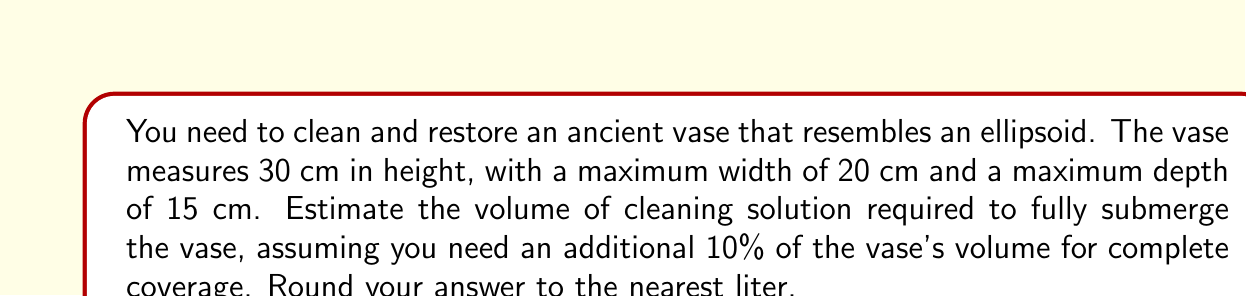Provide a solution to this math problem. To solve this problem, we'll follow these steps:

1) The vase is described as an ellipsoid. The volume of an ellipsoid is given by the formula:

   $$V = \frac{4}{3}\pi abc$$

   where $a$, $b$, and $c$ are the semi-axes of the ellipsoid.

2) Given the dimensions:
   Height = 30 cm, so $c = 15$ cm
   Width = 20 cm, so $a = 10$ cm
   Depth = 15 cm, so $b = 7.5$ cm

3) Substituting these values into the formula:

   $$V = \frac{4}{3}\pi(10)(7.5)(15)$$

4) Simplify:
   $$V = \frac{4}{3}\pi(1125) = 1500\pi \approx 4712.39 \text{ cm}^3$$

5) Convert to liters:
   $$4712.39 \text{ cm}^3 = 4.71239 \text{ liters}$$

6) Add 10% for complete coverage:
   $$4.71239 \times 1.1 = 5.183629 \text{ liters}$$

7) Rounding to the nearest liter:
   $$5.183629 \text{ liters} \approx 5 \text{ liters}$$
Answer: 5 liters 